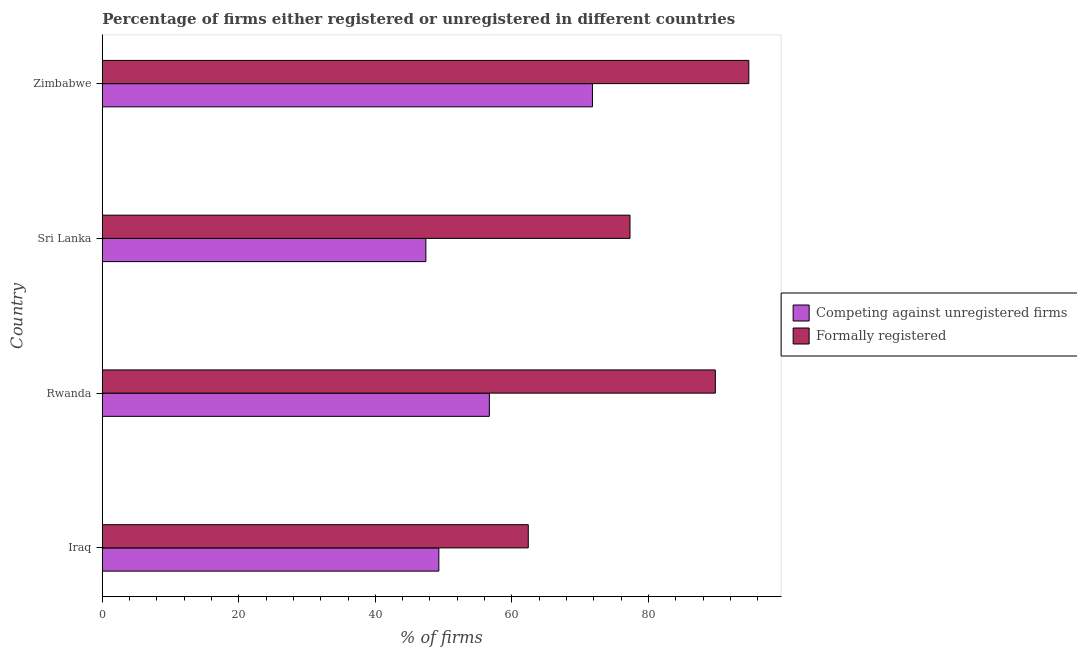How many different coloured bars are there?
Provide a short and direct response. 2. Are the number of bars per tick equal to the number of legend labels?
Your answer should be very brief. Yes. What is the label of the 1st group of bars from the top?
Your answer should be very brief. Zimbabwe. What is the percentage of formally registered firms in Zimbabwe?
Offer a very short reply. 94.7. Across all countries, what is the maximum percentage of registered firms?
Make the answer very short. 71.8. Across all countries, what is the minimum percentage of formally registered firms?
Give a very brief answer. 62.4. In which country was the percentage of formally registered firms maximum?
Provide a succinct answer. Zimbabwe. In which country was the percentage of formally registered firms minimum?
Keep it short and to the point. Iraq. What is the total percentage of formally registered firms in the graph?
Offer a terse response. 324.2. What is the difference between the percentage of formally registered firms in Sri Lanka and that in Zimbabwe?
Keep it short and to the point. -17.4. What is the difference between the percentage of registered firms in Sri Lanka and the percentage of formally registered firms in Zimbabwe?
Give a very brief answer. -47.3. What is the average percentage of formally registered firms per country?
Your answer should be compact. 81.05. What is the difference between the percentage of registered firms and percentage of formally registered firms in Sri Lanka?
Offer a terse response. -29.9. In how many countries, is the percentage of formally registered firms greater than 56 %?
Make the answer very short. 4. What is the ratio of the percentage of registered firms in Iraq to that in Zimbabwe?
Your answer should be very brief. 0.69. What is the difference between the highest and the lowest percentage of formally registered firms?
Your answer should be very brief. 32.3. Is the sum of the percentage of registered firms in Iraq and Sri Lanka greater than the maximum percentage of formally registered firms across all countries?
Your answer should be very brief. Yes. What does the 2nd bar from the top in Zimbabwe represents?
Ensure brevity in your answer.  Competing against unregistered firms. What does the 1st bar from the bottom in Iraq represents?
Provide a short and direct response. Competing against unregistered firms. Are all the bars in the graph horizontal?
Make the answer very short. Yes. What is the difference between two consecutive major ticks on the X-axis?
Provide a short and direct response. 20. What is the title of the graph?
Offer a very short reply. Percentage of firms either registered or unregistered in different countries. Does "Non-resident workers" appear as one of the legend labels in the graph?
Ensure brevity in your answer.  No. What is the label or title of the X-axis?
Give a very brief answer. % of firms. What is the % of firms in Competing against unregistered firms in Iraq?
Give a very brief answer. 49.3. What is the % of firms of Formally registered in Iraq?
Your response must be concise. 62.4. What is the % of firms of Competing against unregistered firms in Rwanda?
Give a very brief answer. 56.7. What is the % of firms in Formally registered in Rwanda?
Offer a terse response. 89.8. What is the % of firms in Competing against unregistered firms in Sri Lanka?
Your answer should be very brief. 47.4. What is the % of firms of Formally registered in Sri Lanka?
Offer a very short reply. 77.3. What is the % of firms in Competing against unregistered firms in Zimbabwe?
Offer a very short reply. 71.8. What is the % of firms in Formally registered in Zimbabwe?
Keep it short and to the point. 94.7. Across all countries, what is the maximum % of firms of Competing against unregistered firms?
Keep it short and to the point. 71.8. Across all countries, what is the maximum % of firms in Formally registered?
Offer a very short reply. 94.7. Across all countries, what is the minimum % of firms in Competing against unregistered firms?
Offer a very short reply. 47.4. Across all countries, what is the minimum % of firms in Formally registered?
Keep it short and to the point. 62.4. What is the total % of firms in Competing against unregistered firms in the graph?
Make the answer very short. 225.2. What is the total % of firms in Formally registered in the graph?
Offer a terse response. 324.2. What is the difference between the % of firms of Competing against unregistered firms in Iraq and that in Rwanda?
Ensure brevity in your answer.  -7.4. What is the difference between the % of firms of Formally registered in Iraq and that in Rwanda?
Keep it short and to the point. -27.4. What is the difference between the % of firms in Competing against unregistered firms in Iraq and that in Sri Lanka?
Give a very brief answer. 1.9. What is the difference between the % of firms in Formally registered in Iraq and that in Sri Lanka?
Offer a very short reply. -14.9. What is the difference between the % of firms in Competing against unregistered firms in Iraq and that in Zimbabwe?
Make the answer very short. -22.5. What is the difference between the % of firms in Formally registered in Iraq and that in Zimbabwe?
Keep it short and to the point. -32.3. What is the difference between the % of firms in Formally registered in Rwanda and that in Sri Lanka?
Your answer should be compact. 12.5. What is the difference between the % of firms of Competing against unregistered firms in Rwanda and that in Zimbabwe?
Provide a succinct answer. -15.1. What is the difference between the % of firms of Competing against unregistered firms in Sri Lanka and that in Zimbabwe?
Make the answer very short. -24.4. What is the difference between the % of firms in Formally registered in Sri Lanka and that in Zimbabwe?
Keep it short and to the point. -17.4. What is the difference between the % of firms of Competing against unregistered firms in Iraq and the % of firms of Formally registered in Rwanda?
Offer a terse response. -40.5. What is the difference between the % of firms of Competing against unregistered firms in Iraq and the % of firms of Formally registered in Zimbabwe?
Your answer should be very brief. -45.4. What is the difference between the % of firms of Competing against unregistered firms in Rwanda and the % of firms of Formally registered in Sri Lanka?
Make the answer very short. -20.6. What is the difference between the % of firms in Competing against unregistered firms in Rwanda and the % of firms in Formally registered in Zimbabwe?
Ensure brevity in your answer.  -38. What is the difference between the % of firms of Competing against unregistered firms in Sri Lanka and the % of firms of Formally registered in Zimbabwe?
Provide a succinct answer. -47.3. What is the average % of firms of Competing against unregistered firms per country?
Provide a short and direct response. 56.3. What is the average % of firms in Formally registered per country?
Provide a short and direct response. 81.05. What is the difference between the % of firms in Competing against unregistered firms and % of firms in Formally registered in Rwanda?
Your answer should be very brief. -33.1. What is the difference between the % of firms in Competing against unregistered firms and % of firms in Formally registered in Sri Lanka?
Provide a short and direct response. -29.9. What is the difference between the % of firms in Competing against unregistered firms and % of firms in Formally registered in Zimbabwe?
Ensure brevity in your answer.  -22.9. What is the ratio of the % of firms in Competing against unregistered firms in Iraq to that in Rwanda?
Provide a short and direct response. 0.87. What is the ratio of the % of firms in Formally registered in Iraq to that in Rwanda?
Provide a short and direct response. 0.69. What is the ratio of the % of firms of Competing against unregistered firms in Iraq to that in Sri Lanka?
Give a very brief answer. 1.04. What is the ratio of the % of firms in Formally registered in Iraq to that in Sri Lanka?
Offer a terse response. 0.81. What is the ratio of the % of firms in Competing against unregistered firms in Iraq to that in Zimbabwe?
Ensure brevity in your answer.  0.69. What is the ratio of the % of firms in Formally registered in Iraq to that in Zimbabwe?
Your answer should be very brief. 0.66. What is the ratio of the % of firms of Competing against unregistered firms in Rwanda to that in Sri Lanka?
Your answer should be very brief. 1.2. What is the ratio of the % of firms of Formally registered in Rwanda to that in Sri Lanka?
Provide a succinct answer. 1.16. What is the ratio of the % of firms in Competing against unregistered firms in Rwanda to that in Zimbabwe?
Provide a short and direct response. 0.79. What is the ratio of the % of firms of Formally registered in Rwanda to that in Zimbabwe?
Make the answer very short. 0.95. What is the ratio of the % of firms of Competing against unregistered firms in Sri Lanka to that in Zimbabwe?
Make the answer very short. 0.66. What is the ratio of the % of firms in Formally registered in Sri Lanka to that in Zimbabwe?
Provide a short and direct response. 0.82. What is the difference between the highest and the second highest % of firms in Competing against unregistered firms?
Your answer should be very brief. 15.1. What is the difference between the highest and the second highest % of firms of Formally registered?
Your answer should be very brief. 4.9. What is the difference between the highest and the lowest % of firms in Competing against unregistered firms?
Keep it short and to the point. 24.4. What is the difference between the highest and the lowest % of firms of Formally registered?
Offer a very short reply. 32.3. 